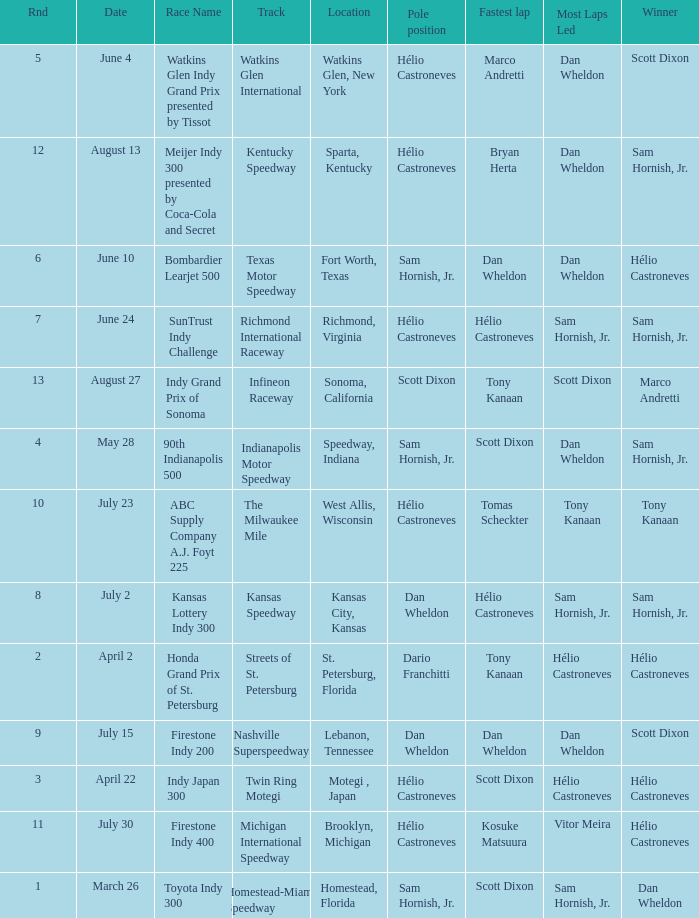How many times is the location is homestead, florida? 1.0. 